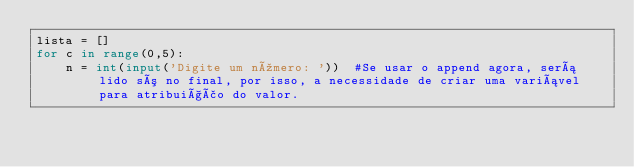Convert code to text. <code><loc_0><loc_0><loc_500><loc_500><_Python_>lista = []
for c in range(0,5):
    n = int(input('Digite um número: '))  #Se usar o append agora, será lido só no final, por isso, a necessidade de criar uma variável para atribuição do valor.</code> 